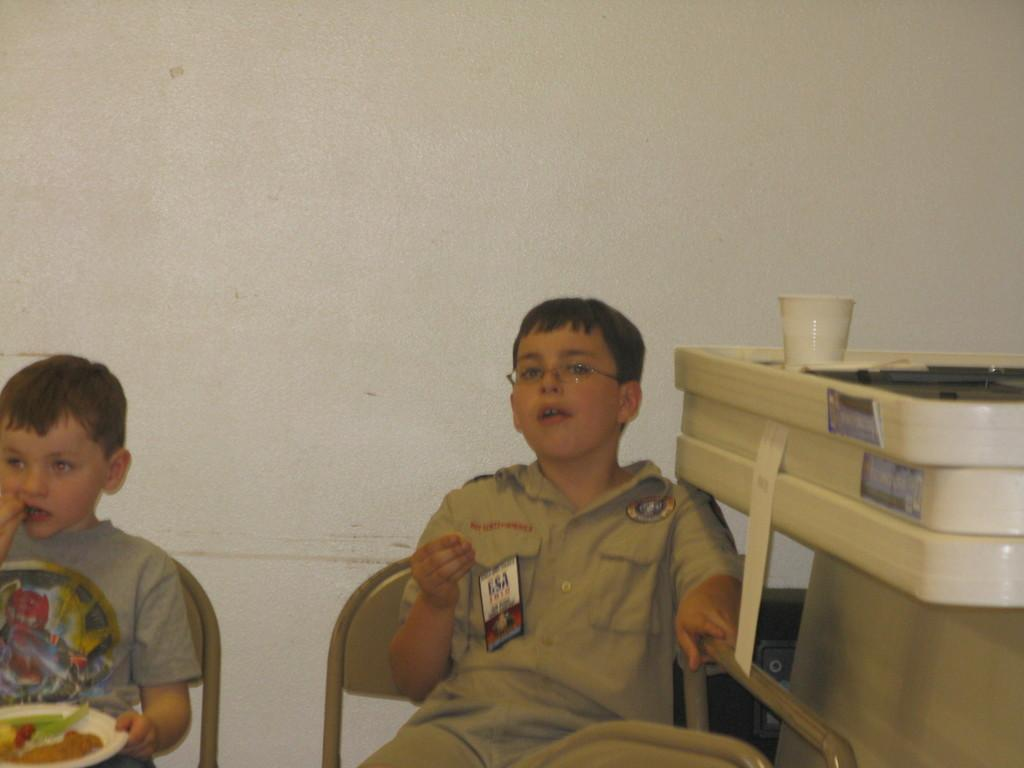How many kids are in the image? There are two kids in the image. What are the kids doing in the image? The kids are sitting on chairs. Where are the chairs located in relation to the wall? The chairs are in front of a wall. Can you describe the object that has a cup on it? Unfortunately, the facts provided do not give enough information to describe the object with the cup on it. What type of powder is the mom using to clean the chairs in the image? There is no mom present in the image, and no cleaning activity is depicted. 